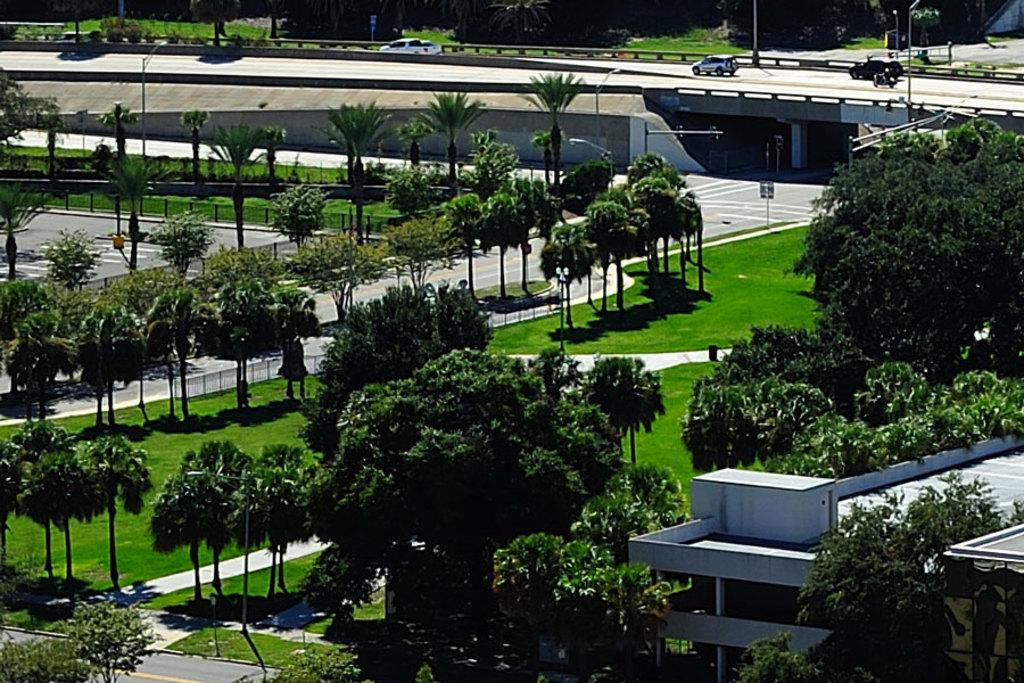What type of vegetation is present in the image? There are many trees in the image. What covers the ground in the image? The ground is covered with grass. What type of structure can be seen in the image? There is a building in the image. What type of vehicles are parked on the road in the image? Cars are parked on the road in the image. Where is the zipper located in the image? There is no zipper present in the image. What type of industry can be seen in the image? The image does not depict any industry; it features trees, grass, a building, and parked cars. 